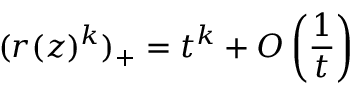<formula> <loc_0><loc_0><loc_500><loc_500>( r ( z ) ^ { k } ) _ { + } = t ^ { k } + O \left ( \frac { 1 } { t } \right )</formula> 